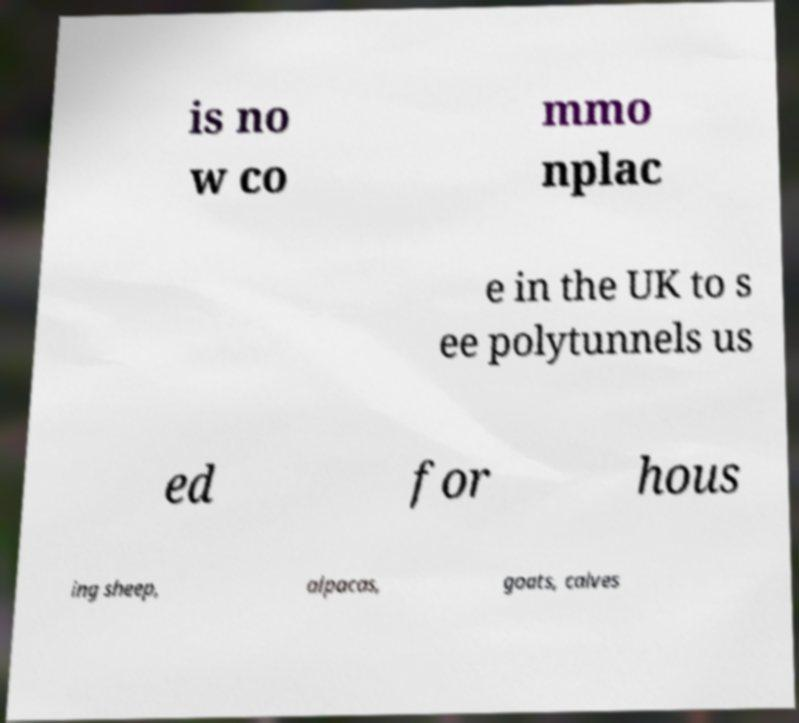What messages or text are displayed in this image? I need them in a readable, typed format. is no w co mmo nplac e in the UK to s ee polytunnels us ed for hous ing sheep, alpacas, goats, calves 